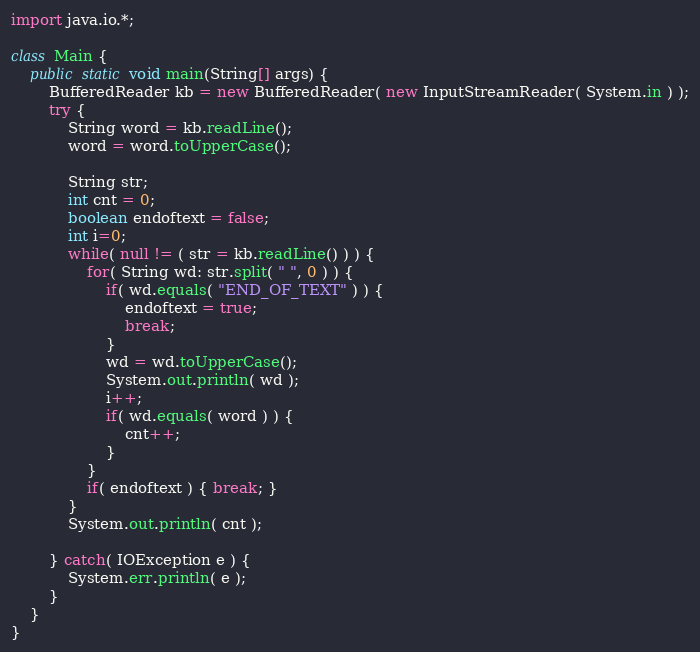<code> <loc_0><loc_0><loc_500><loc_500><_Java_>import java.io.*;

class Main {
	public static void main(String[] args) {
		BufferedReader kb = new BufferedReader( new InputStreamReader( System.in ) );
		try {
	        String word = kb.readLine();
	        word = word.toUpperCase();
	        
	        String str;
	        int cnt = 0;
	       	boolean endoftext = false;
	       	int i=0;
	        while( null != ( str = kb.readLine() ) ) {
	        	for( String wd: str.split( " ", 0 ) ) {
					if( wd.equals( "END_OF_TEXT" ) ) {
		        		endoftext = true;
		        		break;
		        	}
		        	wd = wd.toUpperCase();
		        	System.out.println( wd );
		        	i++;
		        	if( wd.equals( word ) ) {
		        		cnt++;
		        	}
		        }
	        	if( endoftext ) { break; }
	        }
			System.out.println( cnt );
			
		} catch( IOException e ) {
			System.err.println( e );
		}
	}
}</code> 